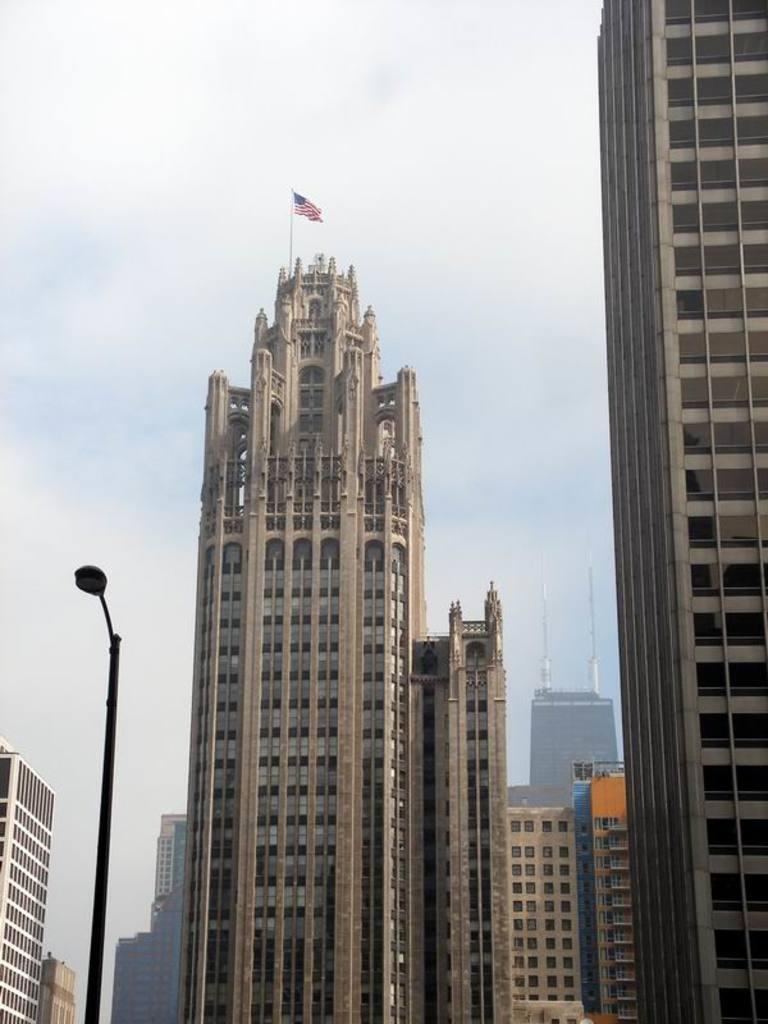What type of structures are present in the image? There are buildings in the image. Can you describe any specific features of the buildings? There is a flag at the top of one of the buildings. What else can be seen in the image besides the buildings? There is a street light in the image. What is visible in the background of the image? The sky is visible in the image. How many ladybugs can be seen crawling on the buildings in the image? There are no ladybugs present in the image; it only features buildings, a flag, a street light, and the sky. 